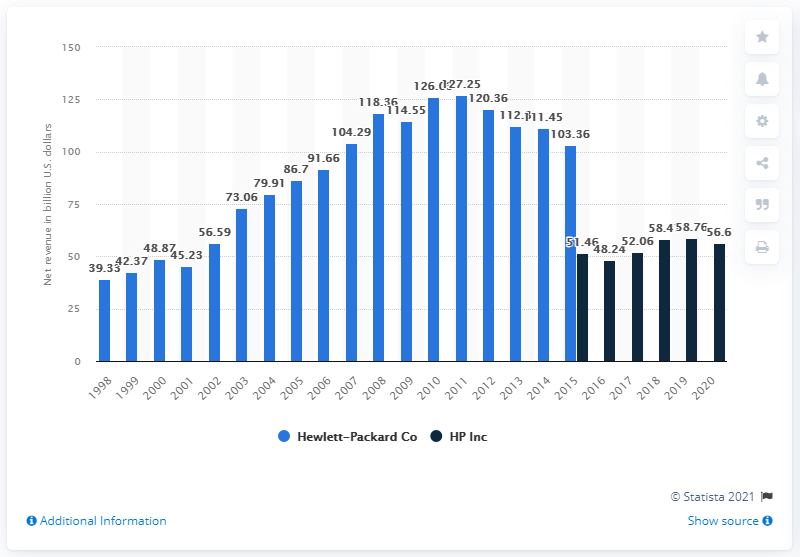Give some essential details in this illustration. In the 2020 fiscal year, HP generated approximately $56.6 billion in revenue. 